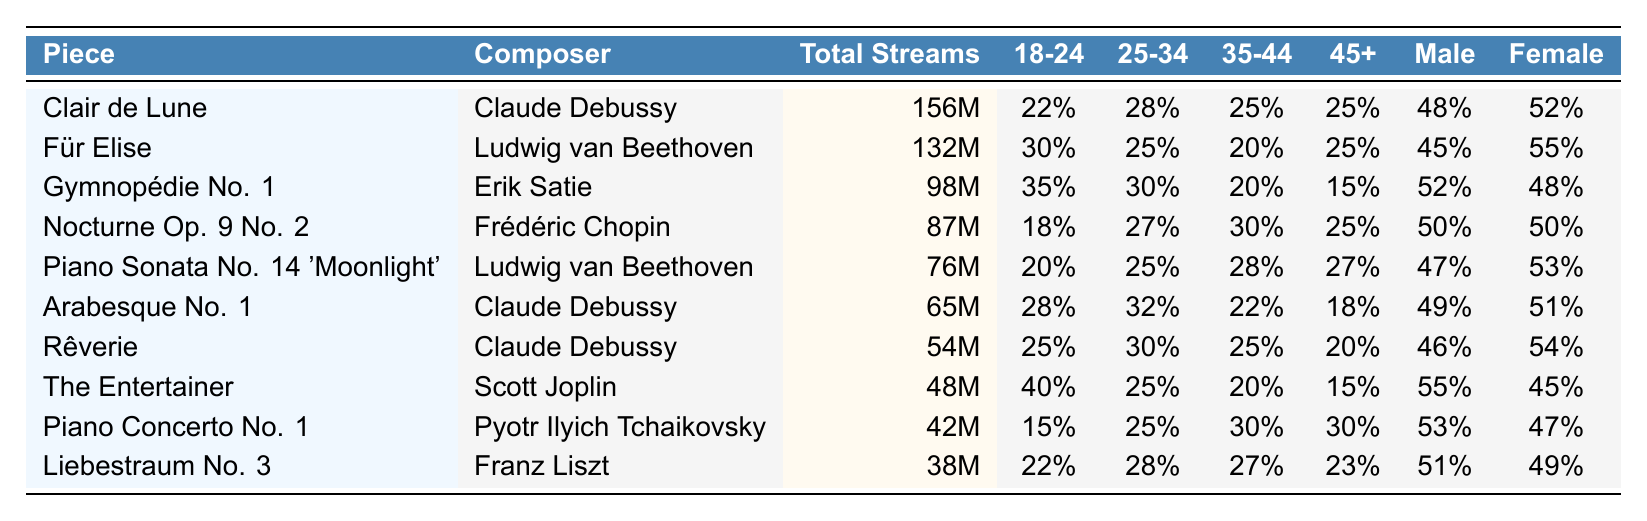What is the total number of streams for "Clair de Lune"? The table shows the total streams for each piece. For "Clair de Lune," the value given is 156 million.
Answer: 156 million Which composer is associated with the piece "Für Elise"? The table lists the composers next to their corresponding pieces. "Für Elise" is composed by Ludwig van Beethoven.
Answer: Ludwig van Beethoven What percentage of listeners aged 18-24 listen to "Gymnopédie No. 1"? In the table, the percentage of listeners aged 18-24 for "Gymnopédie No. 1" is provided as 35%.
Answer: 35% Which piece has the highest percentage of listeners aged 45 and older? By comparing the percentages in the "45+" column, "Piano Concerto No. 1" and "Nocturne Op. 9 No. 2" both have 30%. Therefore, they share the highest percentage for that age group.
Answer: Piano Concerto No. 1 and Nocturne Op. 9 No. 2 What is the average percentage of female listeners across all pieces? To find the average: (52 + 55 + 48 + 50 + 53 + 51 + 54 + 45 + 47 + 49) = 499. Then divide by 10 (the number of pieces), so 499/10 = 49.9%.
Answer: 49.9% Is "The Entertainer" more popular among males or females? For "The Entertainer," the percentage of male listeners is 55% and female listeners is 45%. Since 55% is greater, it has more male listeners.
Answer: Males Which piece has the lowest total streams and what is that amount? Looking at the "Total Streams" column, "Liebestraum No. 3" has the lowest total with 38 million streams.
Answer: 38 million What is the difference in the total streams between "Clair de Lune" and "Für Elise"? The total streams for "Clair de Lune" is 156 million and for "Für Elise" is 132 million. The difference is 156 million - 132 million = 24 million.
Answer: 24 million What percentage of listeners aged 35-44 enjoy "Nocturne Op. 9 No. 2"? According to the table, the percentage of listeners aged 35-44 for "Nocturne Op. 9 No. 2" is 30%.
Answer: 30% How many pieces have more than 50 million total streams? By reviewing the "Total Streams" values, "Clair de Lune," "Für Elise," "Gymnopédie No. 1," "Nocturne Op. 9 No. 2," "Piano Sonata No. 14 'Moonlight,'" "Arabesque No. 1," "Rêverie," and "The Entertainer" total 8 pieces above 50 million.
Answer: 8 Which age group has the highest engagement for "Piano Sonata No. 14 'Moonlight'"? The table indicates that the largest percentage for "Piano Sonata No. 14 'Moonlight'" is in the age group 35-44, which has 28%.
Answer: Age group 35-44 